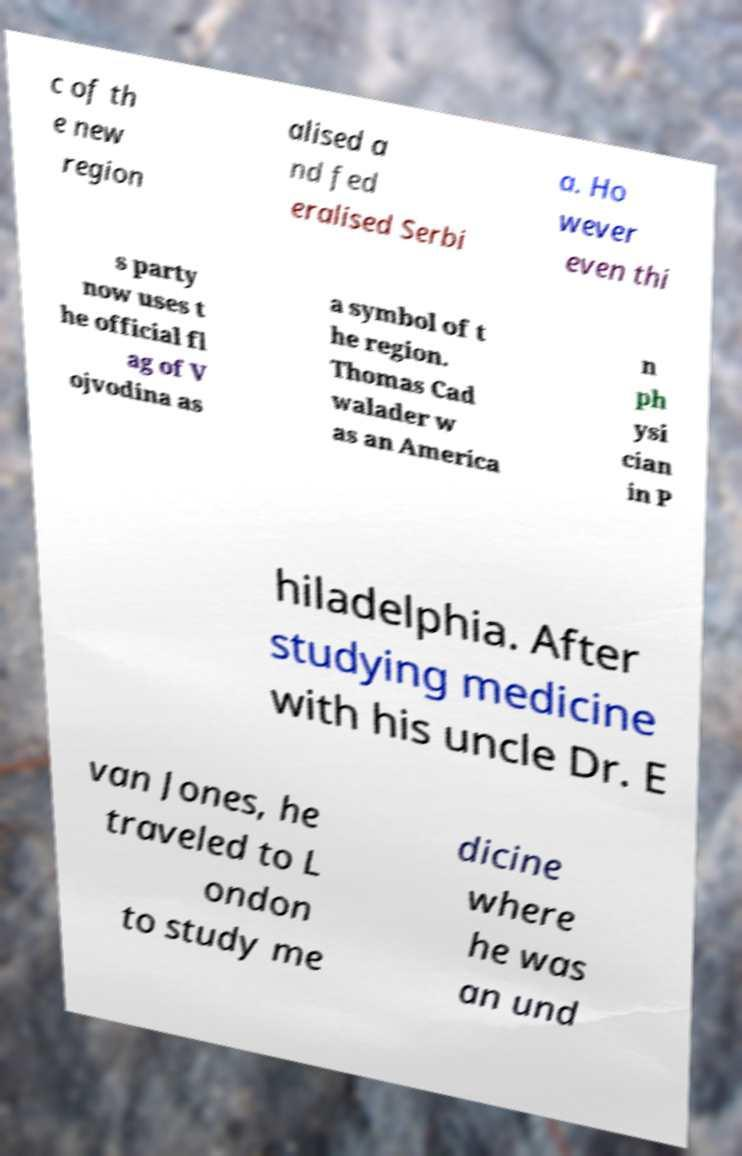Can you read and provide the text displayed in the image?This photo seems to have some interesting text. Can you extract and type it out for me? c of th e new region alised a nd fed eralised Serbi a. Ho wever even thi s party now uses t he official fl ag of V ojvodina as a symbol of t he region. Thomas Cad walader w as an America n ph ysi cian in P hiladelphia. After studying medicine with his uncle Dr. E van Jones, he traveled to L ondon to study me dicine where he was an und 